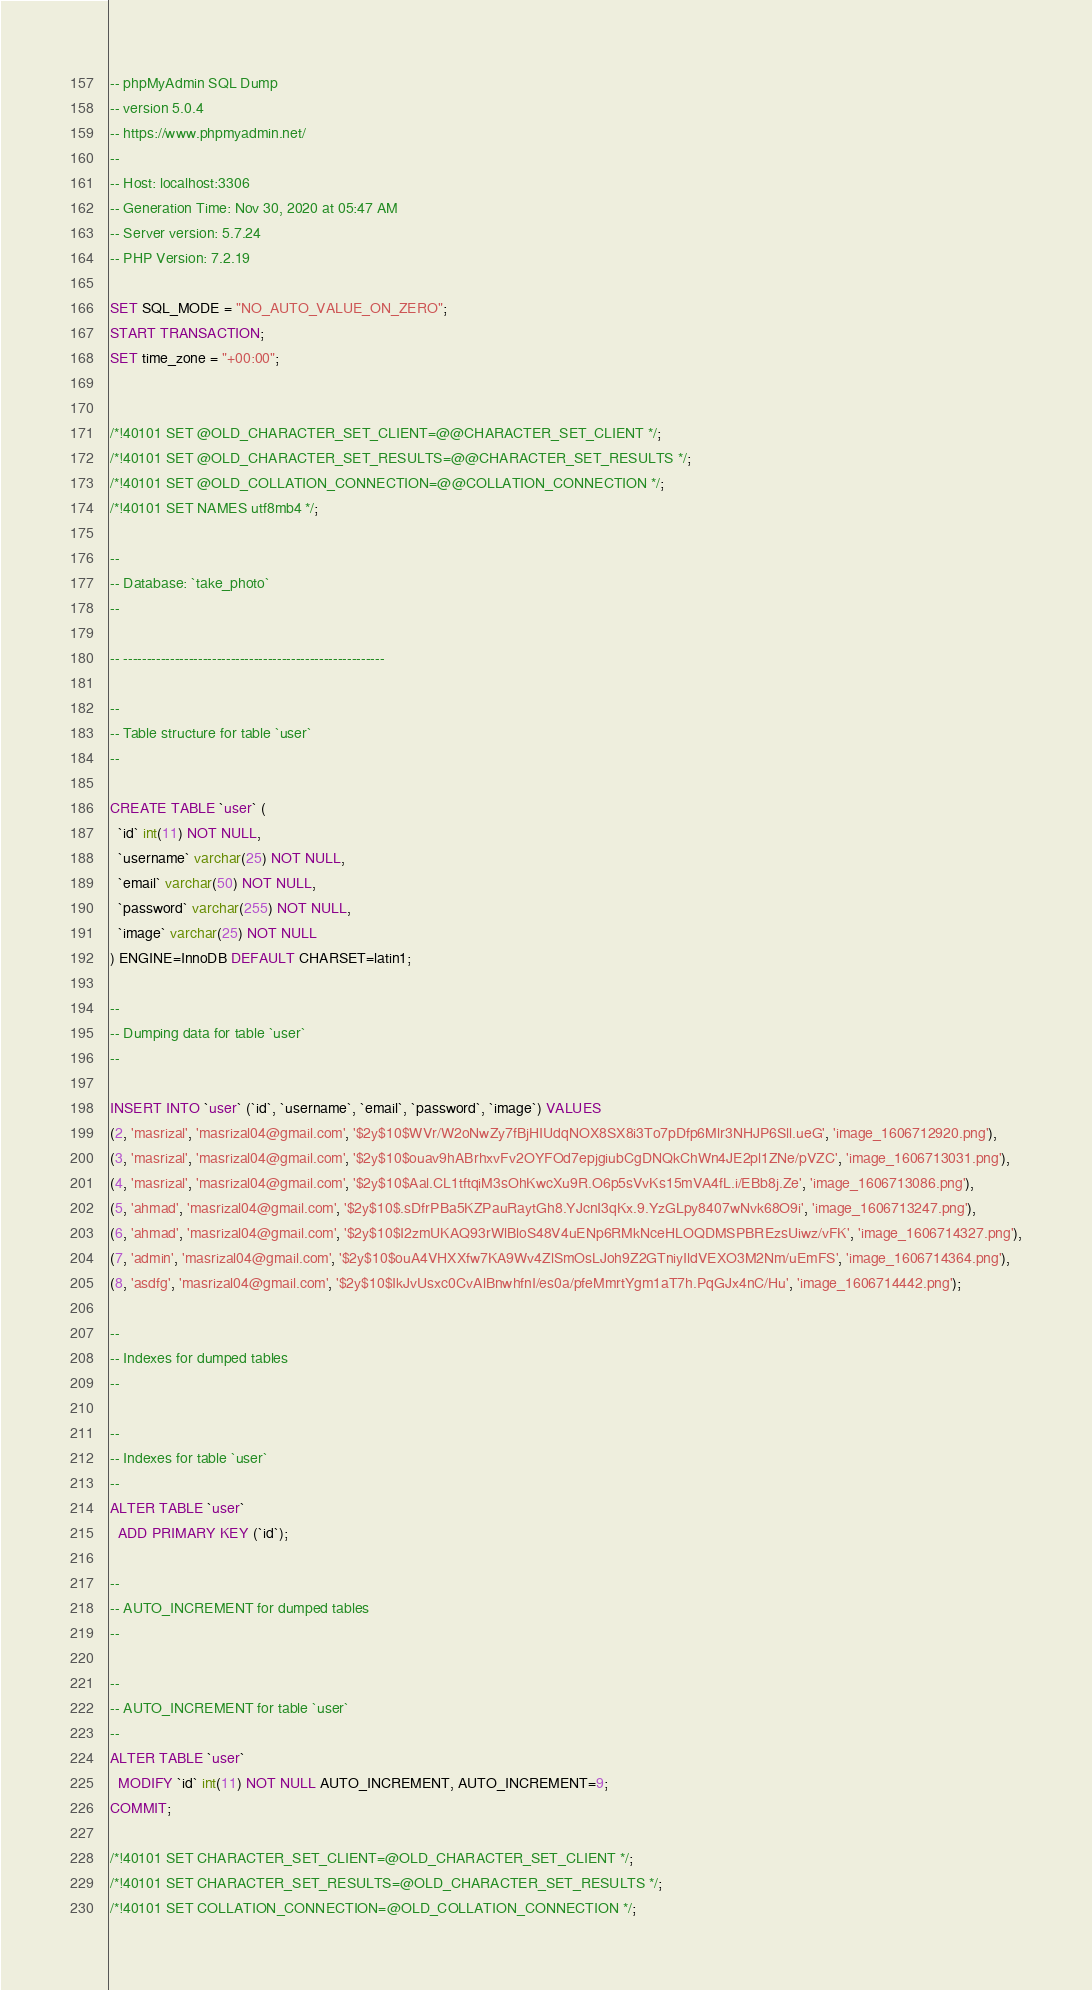Convert code to text. <code><loc_0><loc_0><loc_500><loc_500><_SQL_>-- phpMyAdmin SQL Dump
-- version 5.0.4
-- https://www.phpmyadmin.net/
--
-- Host: localhost:3306
-- Generation Time: Nov 30, 2020 at 05:47 AM
-- Server version: 5.7.24
-- PHP Version: 7.2.19

SET SQL_MODE = "NO_AUTO_VALUE_ON_ZERO";
START TRANSACTION;
SET time_zone = "+00:00";


/*!40101 SET @OLD_CHARACTER_SET_CLIENT=@@CHARACTER_SET_CLIENT */;
/*!40101 SET @OLD_CHARACTER_SET_RESULTS=@@CHARACTER_SET_RESULTS */;
/*!40101 SET @OLD_COLLATION_CONNECTION=@@COLLATION_CONNECTION */;
/*!40101 SET NAMES utf8mb4 */;

--
-- Database: `take_photo`
--

-- --------------------------------------------------------

--
-- Table structure for table `user`
--

CREATE TABLE `user` (
  `id` int(11) NOT NULL,
  `username` varchar(25) NOT NULL,
  `email` varchar(50) NOT NULL,
  `password` varchar(255) NOT NULL,
  `image` varchar(25) NOT NULL
) ENGINE=InnoDB DEFAULT CHARSET=latin1;

--
-- Dumping data for table `user`
--

INSERT INTO `user` (`id`, `username`, `email`, `password`, `image`) VALUES
(2, 'masrizal', 'masrizal04@gmail.com', '$2y$10$WVr/W2oNwZy7fBjHIUdqNOX8SX8i3To7pDfp6Mlr3NHJP6Sll.ueG', 'image_1606712920.png'),
(3, 'masrizal', 'masrizal04@gmail.com', '$2y$10$ouav9hABrhxvFv2OYFOd7epjgiubCgDNQkChWn4JE2pl1ZNe/pVZC', 'image_1606713031.png'),
(4, 'masrizal', 'masrizal04@gmail.com', '$2y$10$Aal.CL1tftqiM3sOhKwcXu9R.O6p5sVvKs15mVA4fL.i/EBb8j.Ze', 'image_1606713086.png'),
(5, 'ahmad', 'masrizal04@gmail.com', '$2y$10$.sDfrPBa5KZPauRaytGh8.YJcnI3qKx.9.YzGLpy8407wNvk68O9i', 'image_1606713247.png'),
(6, 'ahmad', 'masrizal04@gmail.com', '$2y$10$I2zmUKAQ93rWlBloS48V4uENp6RMkNceHLOQDMSPBREzsUiwz/vFK', 'image_1606714327.png'),
(7, 'admin', 'masrizal04@gmail.com', '$2y$10$ouA4VHXXfw7KA9Wv4ZlSmOsLJoh9Z2GTniyIldVEXO3M2Nm/uEmFS', 'image_1606714364.png'),
(8, 'asdfg', 'masrizal04@gmail.com', '$2y$10$IkJvUsxc0CvAlBnwhfnI/es0a/pfeMmrtYgm1aT7h.PqGJx4nC/Hu', 'image_1606714442.png');

--
-- Indexes for dumped tables
--

--
-- Indexes for table `user`
--
ALTER TABLE `user`
  ADD PRIMARY KEY (`id`);

--
-- AUTO_INCREMENT for dumped tables
--

--
-- AUTO_INCREMENT for table `user`
--
ALTER TABLE `user`
  MODIFY `id` int(11) NOT NULL AUTO_INCREMENT, AUTO_INCREMENT=9;
COMMIT;

/*!40101 SET CHARACTER_SET_CLIENT=@OLD_CHARACTER_SET_CLIENT */;
/*!40101 SET CHARACTER_SET_RESULTS=@OLD_CHARACTER_SET_RESULTS */;
/*!40101 SET COLLATION_CONNECTION=@OLD_COLLATION_CONNECTION */;
</code> 